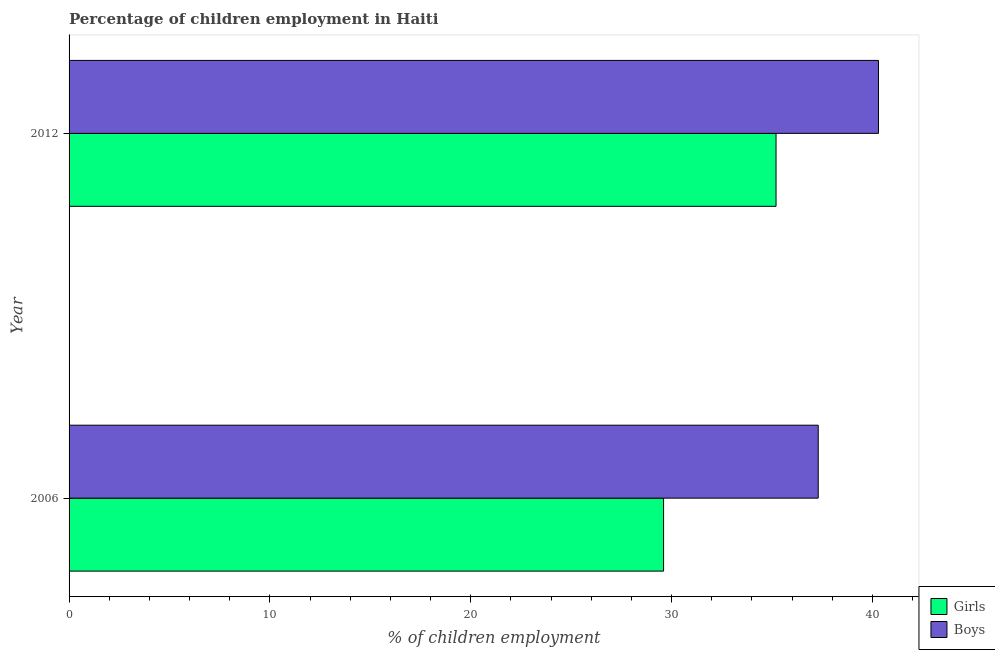How many groups of bars are there?
Give a very brief answer. 2. Are the number of bars on each tick of the Y-axis equal?
Give a very brief answer. Yes. How many bars are there on the 2nd tick from the top?
Keep it short and to the point. 2. How many bars are there on the 1st tick from the bottom?
Your response must be concise. 2. What is the label of the 2nd group of bars from the top?
Provide a succinct answer. 2006. What is the percentage of employed boys in 2006?
Make the answer very short. 37.3. Across all years, what is the maximum percentage of employed boys?
Give a very brief answer. 40.3. Across all years, what is the minimum percentage of employed girls?
Provide a short and direct response. 29.6. What is the total percentage of employed boys in the graph?
Offer a terse response. 77.6. What is the difference between the percentage of employed boys in 2006 and the percentage of employed girls in 2012?
Your response must be concise. 2.1. What is the average percentage of employed girls per year?
Offer a very short reply. 32.4. In how many years, is the percentage of employed boys greater than 18 %?
Make the answer very short. 2. What is the ratio of the percentage of employed girls in 2006 to that in 2012?
Your response must be concise. 0.84. Is the percentage of employed boys in 2006 less than that in 2012?
Make the answer very short. Yes. Is the difference between the percentage of employed girls in 2006 and 2012 greater than the difference between the percentage of employed boys in 2006 and 2012?
Ensure brevity in your answer.  No. In how many years, is the percentage of employed boys greater than the average percentage of employed boys taken over all years?
Provide a short and direct response. 1. What does the 1st bar from the top in 2006 represents?
Your answer should be compact. Boys. What does the 1st bar from the bottom in 2006 represents?
Your answer should be compact. Girls. Are all the bars in the graph horizontal?
Provide a succinct answer. Yes. How many years are there in the graph?
Provide a short and direct response. 2. Are the values on the major ticks of X-axis written in scientific E-notation?
Your answer should be compact. No. Does the graph contain grids?
Ensure brevity in your answer.  No. How many legend labels are there?
Provide a succinct answer. 2. What is the title of the graph?
Provide a succinct answer. Percentage of children employment in Haiti. What is the label or title of the X-axis?
Offer a very short reply. % of children employment. What is the label or title of the Y-axis?
Your answer should be very brief. Year. What is the % of children employment of Girls in 2006?
Make the answer very short. 29.6. What is the % of children employment in Boys in 2006?
Give a very brief answer. 37.3. What is the % of children employment of Girls in 2012?
Provide a short and direct response. 35.2. What is the % of children employment in Boys in 2012?
Ensure brevity in your answer.  40.3. Across all years, what is the maximum % of children employment of Girls?
Give a very brief answer. 35.2. Across all years, what is the maximum % of children employment of Boys?
Keep it short and to the point. 40.3. Across all years, what is the minimum % of children employment of Girls?
Provide a succinct answer. 29.6. Across all years, what is the minimum % of children employment of Boys?
Your answer should be compact. 37.3. What is the total % of children employment in Girls in the graph?
Your response must be concise. 64.8. What is the total % of children employment in Boys in the graph?
Your answer should be very brief. 77.6. What is the difference between the % of children employment of Girls in 2006 and that in 2012?
Offer a very short reply. -5.6. What is the difference between the % of children employment in Boys in 2006 and that in 2012?
Give a very brief answer. -3. What is the average % of children employment in Girls per year?
Your answer should be very brief. 32.4. What is the average % of children employment in Boys per year?
Offer a very short reply. 38.8. What is the ratio of the % of children employment in Girls in 2006 to that in 2012?
Your answer should be compact. 0.84. What is the ratio of the % of children employment in Boys in 2006 to that in 2012?
Ensure brevity in your answer.  0.93. What is the difference between the highest and the lowest % of children employment of Girls?
Give a very brief answer. 5.6. 